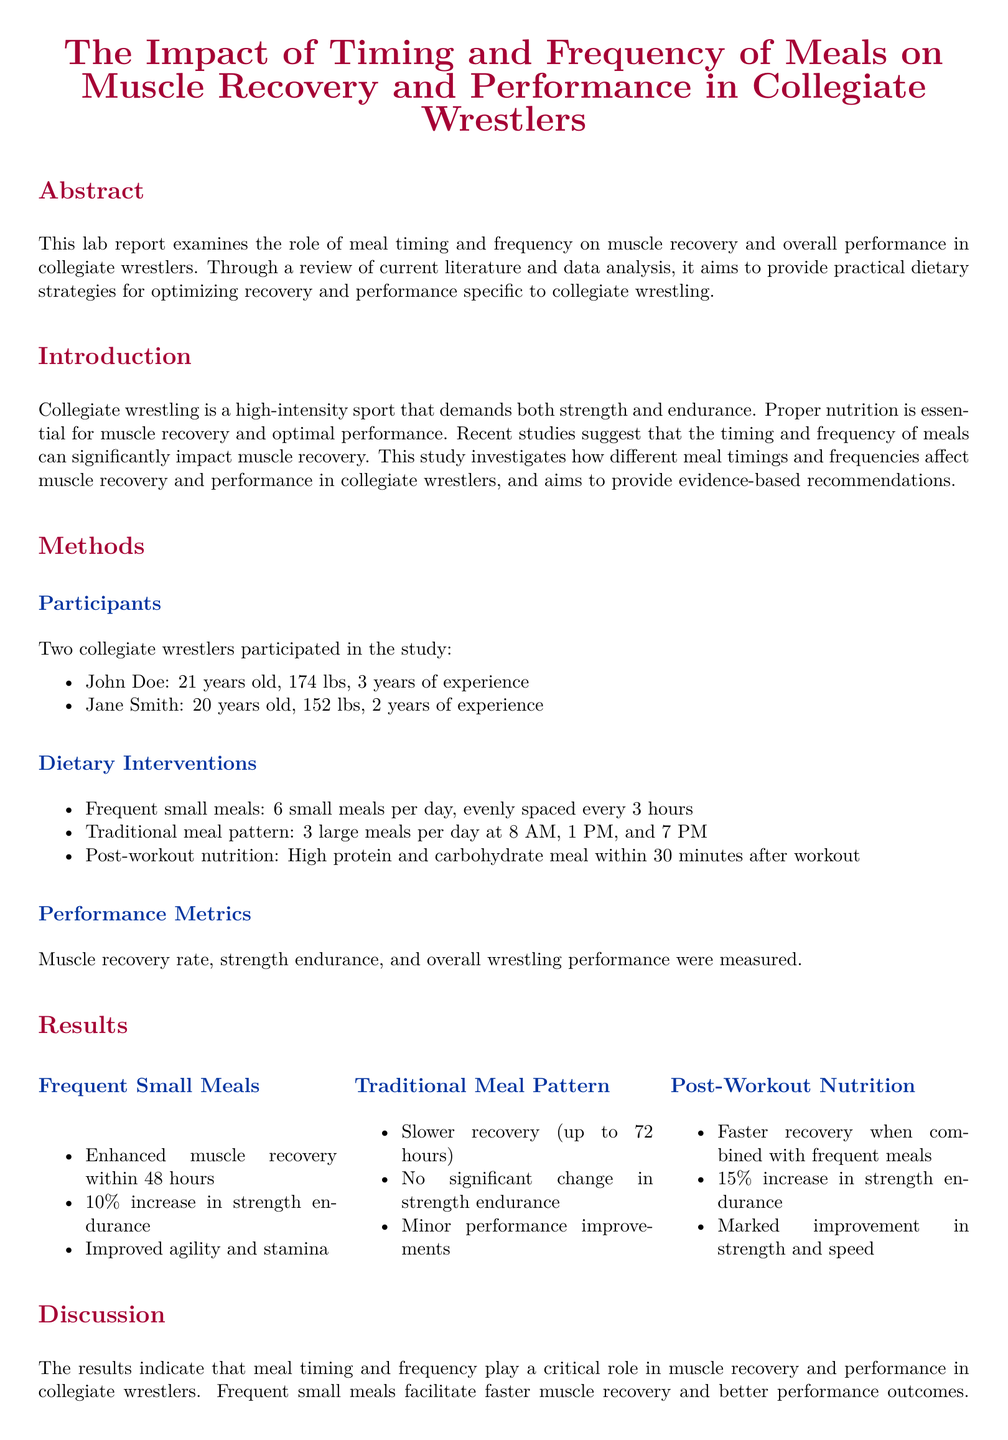What was the primary focus of the study? The primary focus of the study is to examine the role of meal timing and frequency on muscle recovery and performance in collegiate wrestlers.
Answer: Meal timing and frequency Who were the participants in the study? The participants in the study were two collegiate wrestlers named John Doe and Jane Smith.
Answer: John Doe and Jane Smith How many meals were consumed in the frequent small meals intervention? In the frequent small meals intervention, participants consumed 6 small meals per day.
Answer: 6 What was the percentage increase in strength endurance associated with post-workout nutrition? The percentage increase in strength endurance associated with post-workout nutrition was 15 percent.
Answer: 15% Which meal pattern resulted in slower recovery times? The traditional meal pattern resulted in slower recovery times.
Answer: Traditional meal pattern What is one of the recommendations provided in the report? One of the recommendations provided in the report is to consume multiple small meals throughout the day.
Answer: Consume multiple small meals What was the muscle recovery time for frequent small meals? The muscle recovery time for frequent small meals was enhanced within 48 hours.
Answer: 48 hours What improvement did frequent small meals lead to regarding agility? Frequent small meals led to improved agility and stamina.
Answer: Improved agility and stamina 